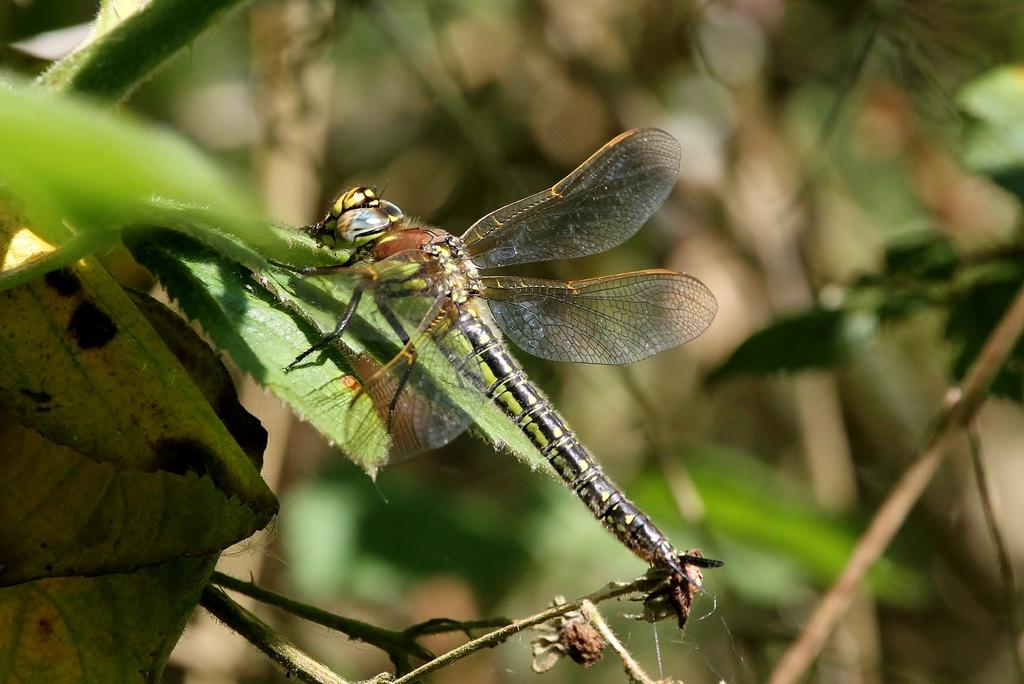What is the main subject of the image? The main subject of the image is an insect. Where is the insect located in the image? The insect is on a leaf. Can you describe the background of the image? The background of the image is blurred. What size shoe is the insect wearing in the image? There is no shoe present in the image, and insects do not wear shoes. 